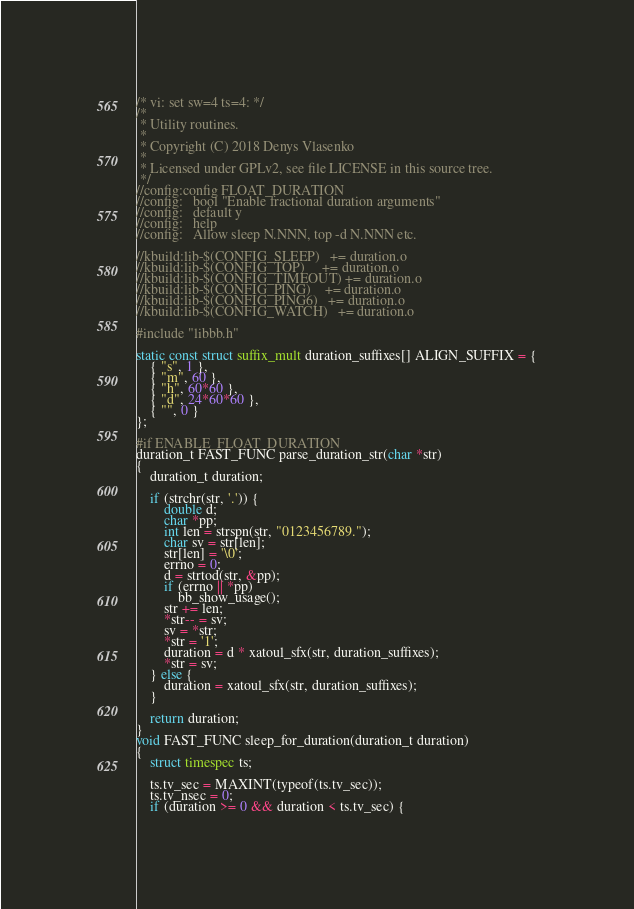<code> <loc_0><loc_0><loc_500><loc_500><_C_>/* vi: set sw=4 ts=4: */
/*
 * Utility routines.
 *
 * Copyright (C) 2018 Denys Vlasenko
 *
 * Licensed under GPLv2, see file LICENSE in this source tree.
 */
//config:config FLOAT_DURATION
//config:	bool "Enable fractional duration arguments"
//config:	default y
//config:	help
//config:	Allow sleep N.NNN, top -d N.NNN etc.

//kbuild:lib-$(CONFIG_SLEEP)   += duration.o
//kbuild:lib-$(CONFIG_TOP)     += duration.o
//kbuild:lib-$(CONFIG_TIMEOUT) += duration.o
//kbuild:lib-$(CONFIG_PING)    += duration.o
//kbuild:lib-$(CONFIG_PING6)   += duration.o
//kbuild:lib-$(CONFIG_WATCH)   += duration.o

#include "libbb.h"

static const struct suffix_mult duration_suffixes[] ALIGN_SUFFIX = {
	{ "s", 1 },
	{ "m", 60 },
	{ "h", 60*60 },
	{ "d", 24*60*60 },
	{ "", 0 }
};

#if ENABLE_FLOAT_DURATION
duration_t FAST_FUNC parse_duration_str(char *str)
{
	duration_t duration;

	if (strchr(str, '.')) {
		double d;
		char *pp;
		int len = strspn(str, "0123456789.");
		char sv = str[len];
		str[len] = '\0';
		errno = 0;
		d = strtod(str, &pp);
		if (errno || *pp)
			bb_show_usage();
		str += len;
		*str-- = sv;
		sv = *str;
		*str = '1';
		duration = d * xatoul_sfx(str, duration_suffixes);
		*str = sv;
	} else {
		duration = xatoul_sfx(str, duration_suffixes);
	}

	return duration;
}
void FAST_FUNC sleep_for_duration(duration_t duration)
{
	struct timespec ts;

	ts.tv_sec = MAXINT(typeof(ts.tv_sec));
	ts.tv_nsec = 0;
	if (duration >= 0 && duration < ts.tv_sec) {</code> 